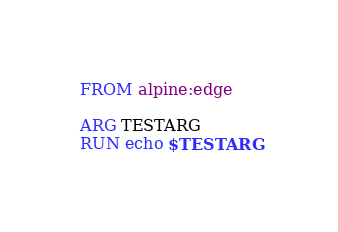<code> <loc_0><loc_0><loc_500><loc_500><_Dockerfile_>FROM alpine:edge

ARG TESTARG
RUN echo $TESTARG</code> 